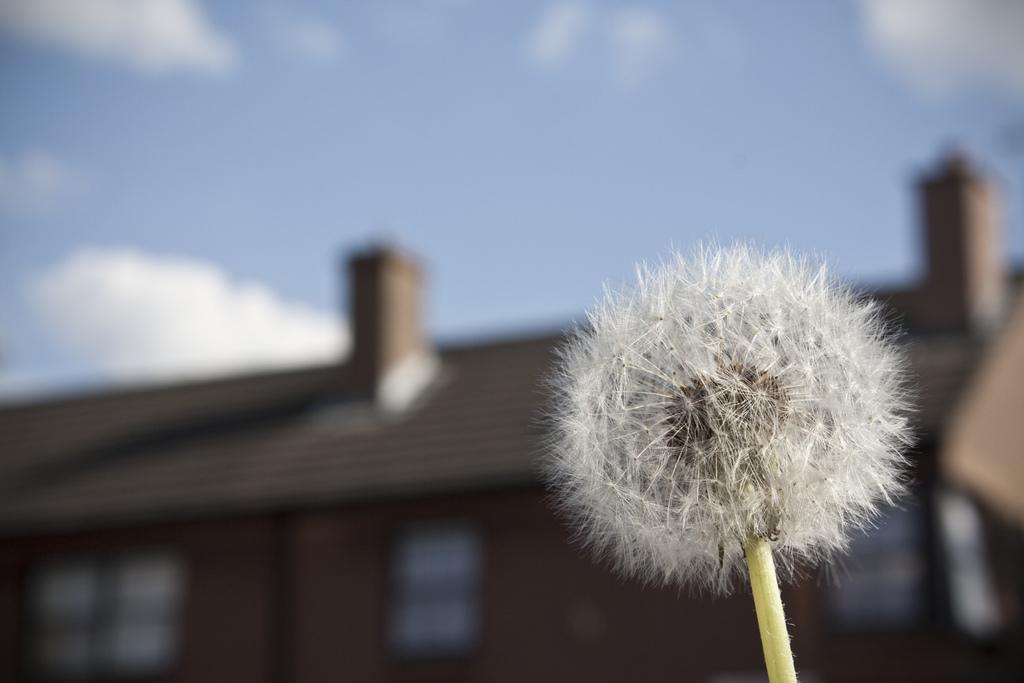Describe this image in one or two sentences. In this image I can see a flower which is white in color to a tree which is green in color. In the background I can see a building, few windows of the building and the sky. 